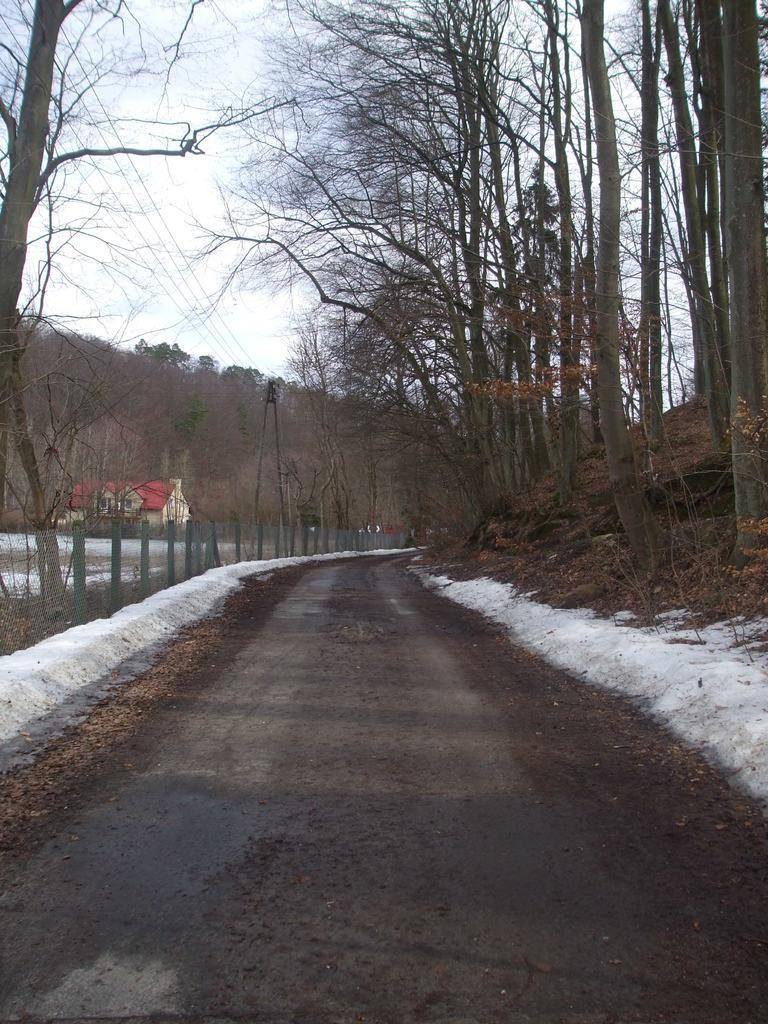What type of vegetation can be seen in the image? There are trees in the image. What type of structure is present in the image? There is a fence and a house in the image. What is the purpose of the current pole in the image? The current pole in the image is likely used for providing electricity. What is visible at the top of the image? The sky is visible at the top of the image. What type of feeling is being expressed by the trees in the image? Trees do not express feelings, as they are inanimate objects. Is there any indication that someone is driving in the image? There is no indication of any vehicles or driving activity in the image. 